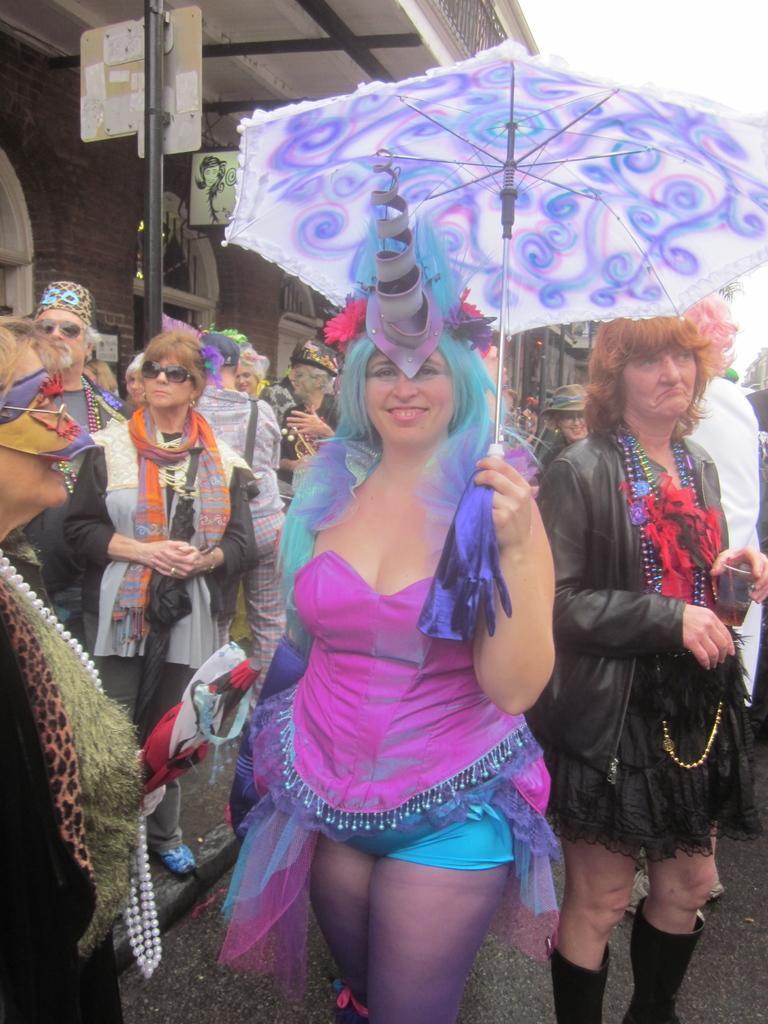Describe this image in one or two sentences. In the image we can see there are people standing on the road and a woman is holding an umbrella in her hand. 